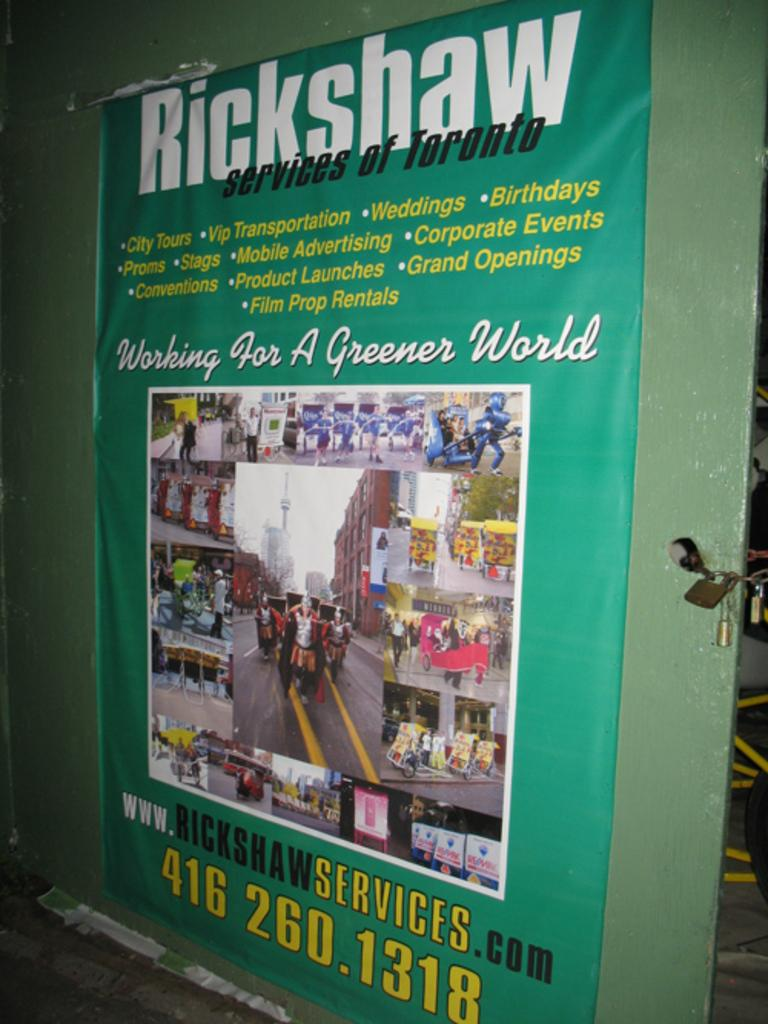<image>
Describe the image concisely. Rickshaw Services has posted a poster on a wall with their phone number and what it is that they do. 